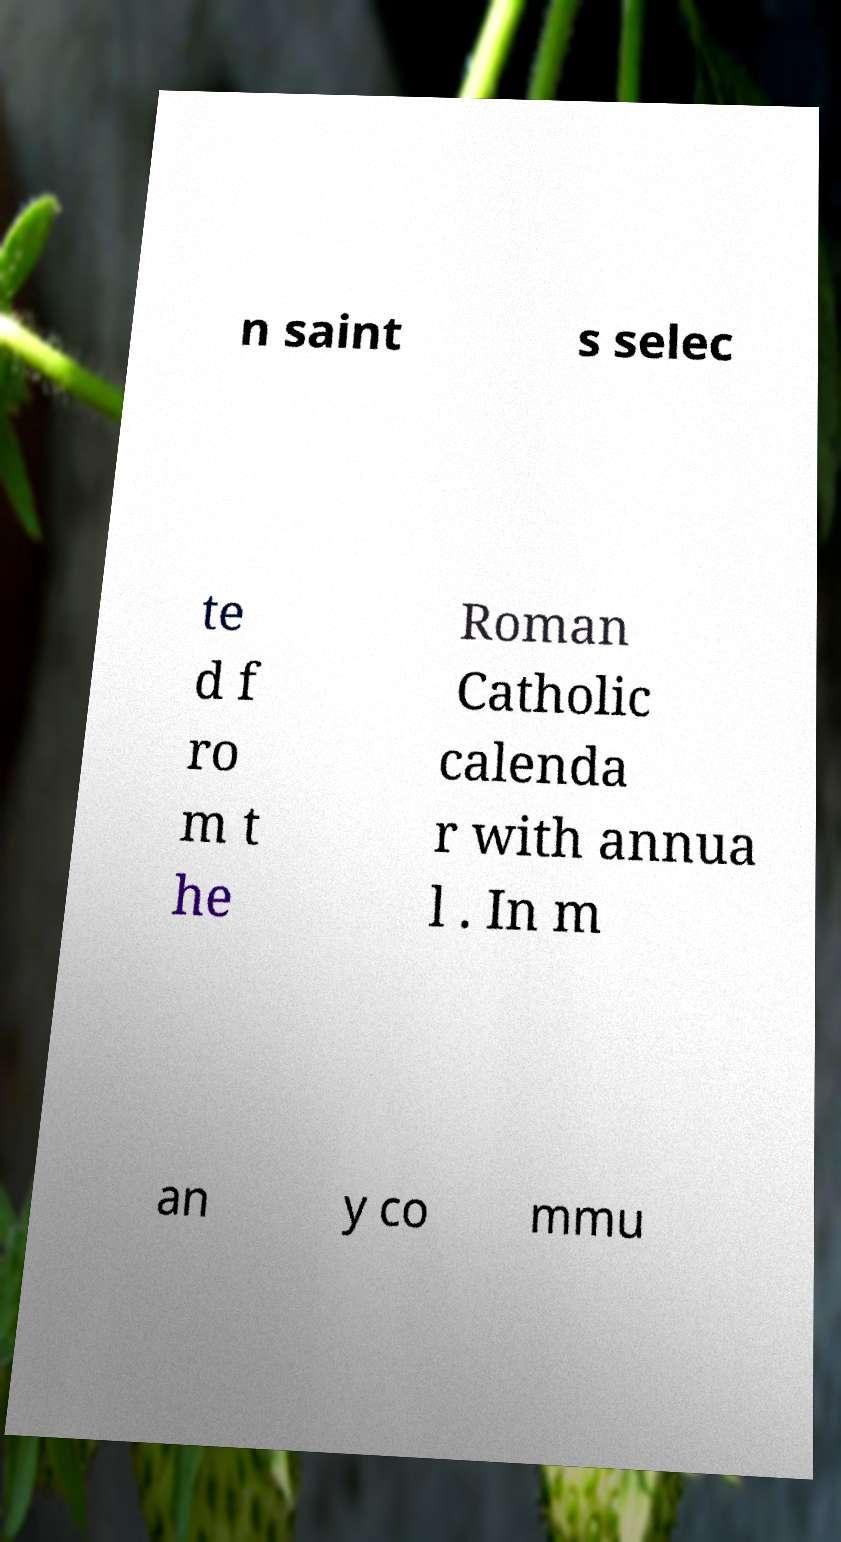What messages or text are displayed in this image? I need them in a readable, typed format. n saint s selec te d f ro m t he Roman Catholic calenda r with annua l . In m an y co mmu 